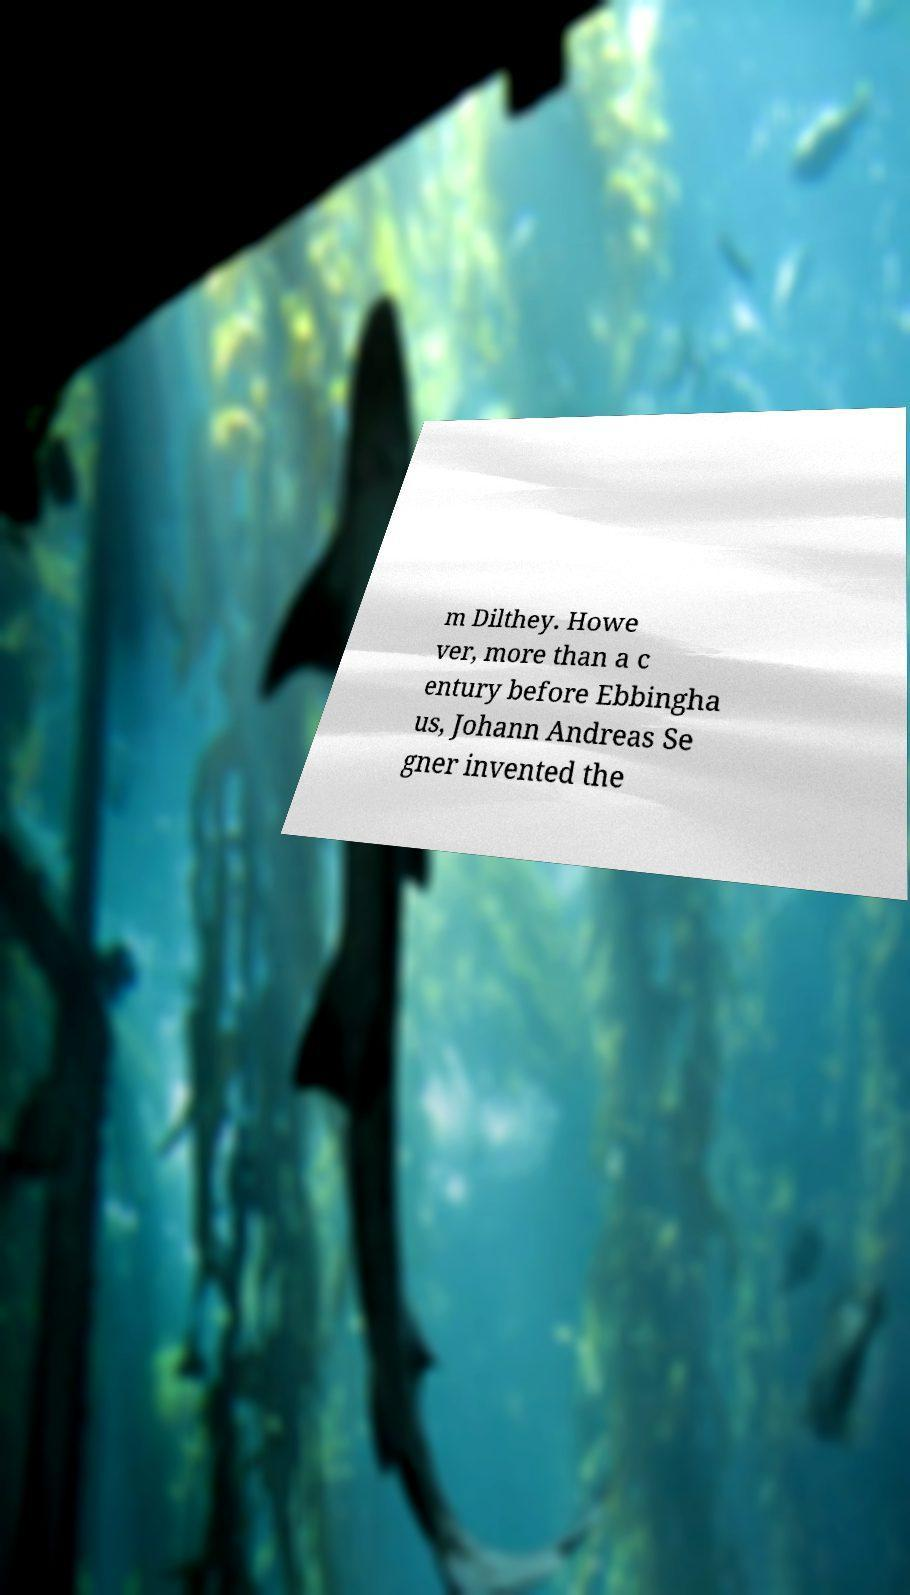Could you extract and type out the text from this image? m Dilthey. Howe ver, more than a c entury before Ebbingha us, Johann Andreas Se gner invented the 